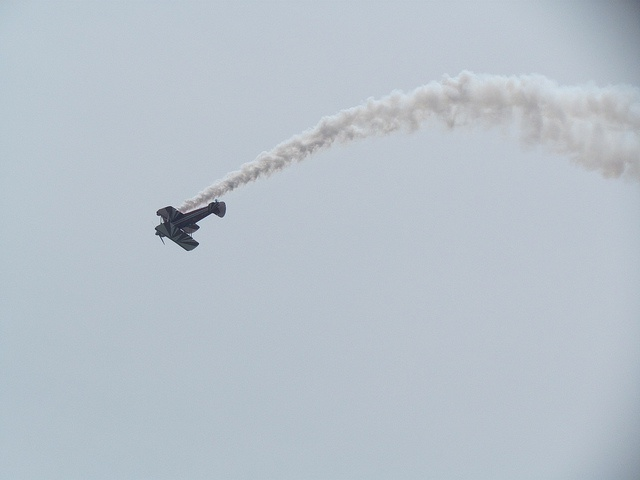Describe the objects in this image and their specific colors. I can see a airplane in lightgray, gray, and black tones in this image. 